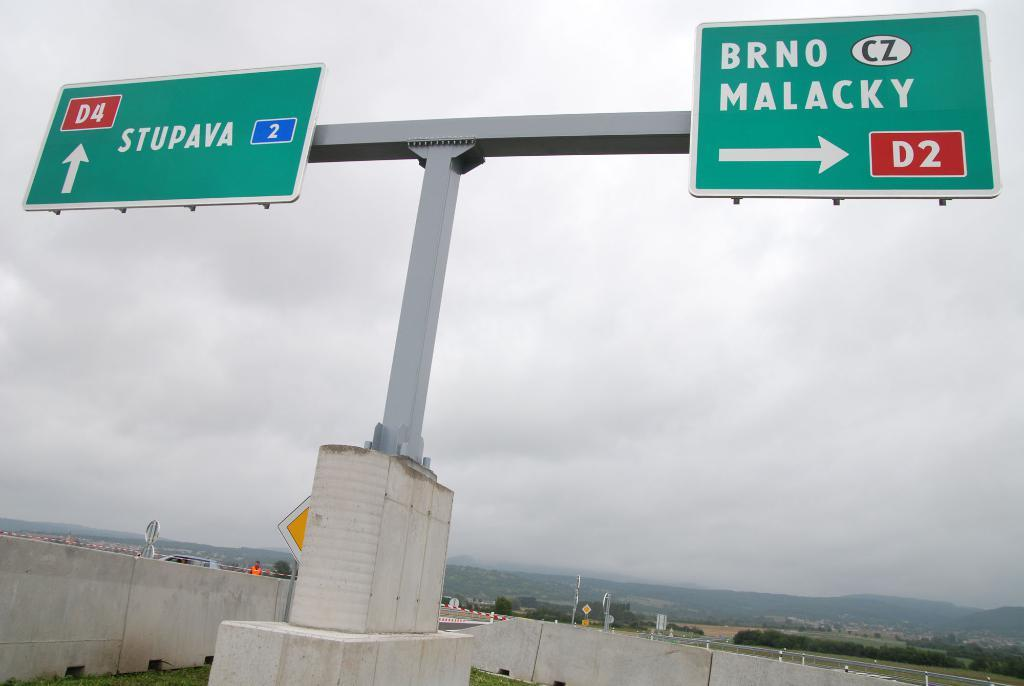<image>
Render a clear and concise summary of the photo. a sign that has the word Malacky on it 